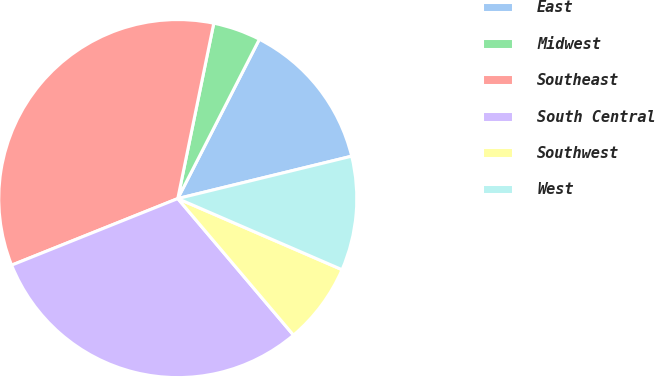Convert chart. <chart><loc_0><loc_0><loc_500><loc_500><pie_chart><fcel>East<fcel>Midwest<fcel>Southeast<fcel>South Central<fcel>Southwest<fcel>West<nl><fcel>13.66%<fcel>4.31%<fcel>34.29%<fcel>30.12%<fcel>7.31%<fcel>10.31%<nl></chart> 